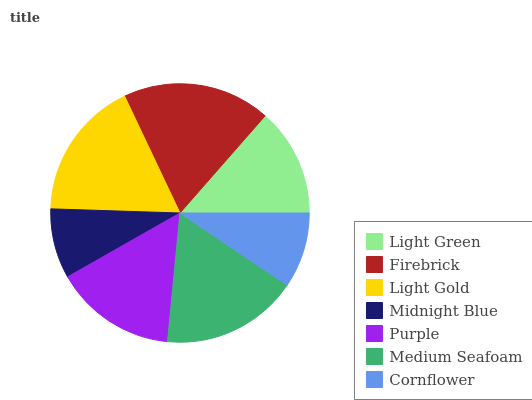Is Midnight Blue the minimum?
Answer yes or no. Yes. Is Firebrick the maximum?
Answer yes or no. Yes. Is Light Gold the minimum?
Answer yes or no. No. Is Light Gold the maximum?
Answer yes or no. No. Is Firebrick greater than Light Gold?
Answer yes or no. Yes. Is Light Gold less than Firebrick?
Answer yes or no. Yes. Is Light Gold greater than Firebrick?
Answer yes or no. No. Is Firebrick less than Light Gold?
Answer yes or no. No. Is Purple the high median?
Answer yes or no. Yes. Is Purple the low median?
Answer yes or no. Yes. Is Light Green the high median?
Answer yes or no. No. Is Firebrick the low median?
Answer yes or no. No. 